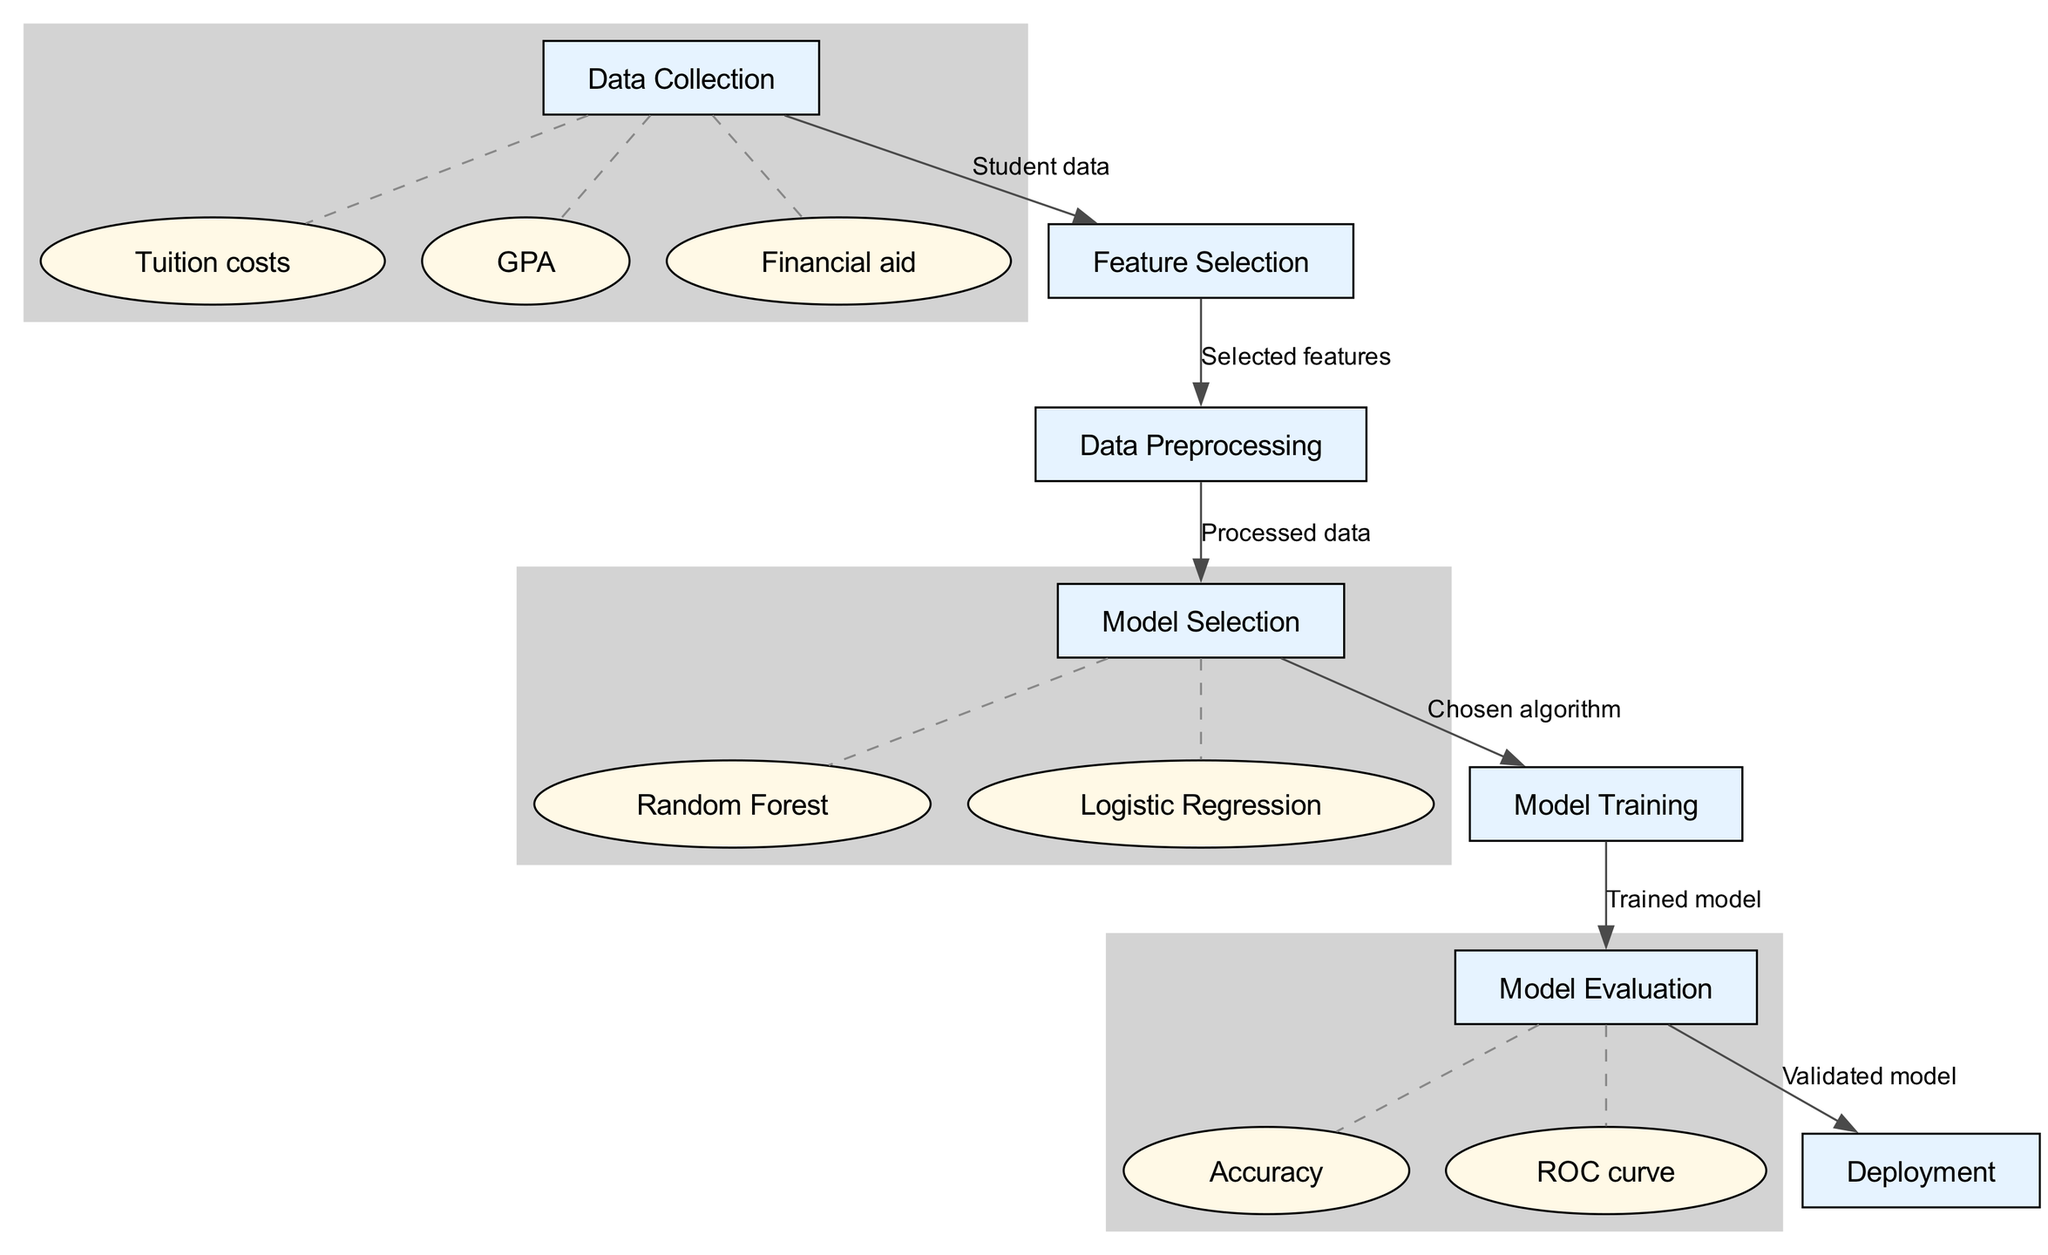What is the first step in the process? The diagram shows that the first step is "Data Collection." This is evident from the first node in the flowchart that is connected to the subsequent steps.
Answer: Data Collection How many main nodes are there in the diagram? By counting the nodes listed, we see there are seven main nodes shown in the nodes section.
Answer: Seven What are the sub-factors included in the Data Collection node? The sub-nodes connected under "Data Collection" indicate the specific factors related to student data, which include Tuition costs, GPA, and Financial aid.
Answer: Tuition costs, GPA, Financial aid What type of algorithm is represented under Model Selection? Two algorithms are specified as sub-nodes under "Model Selection": Random Forest and Logistic Regression. This indicates the type of algorithms considered for model training.
Answer: Random Forest, Logistic Regression What is the final output after all processes are completed? The flowchart indicates that after the last step of the process, which is "Deployment," the validated model is the final output from the machine learning pipeline.
Answer: Validated model What does the edge from Data Preprocessing to Model Selection signify? The edge signifies that after the data has been processed, it moves on to the next step of selecting a model. The connection indicates a direct relationship in the processing flow.
Answer: Processed data How many edges are there in total? By counting all the edges listed, we find there are six connections between the nodes throughout the flowchart.
Answer: Six What is evaluated in the Model Evaluation stage? The diagram shows that two evaluation metrics are indicated under this stage: Accuracy and ROC curve, which evaluate how well the model performs post-training.
Answer: Accuracy, ROC curve 